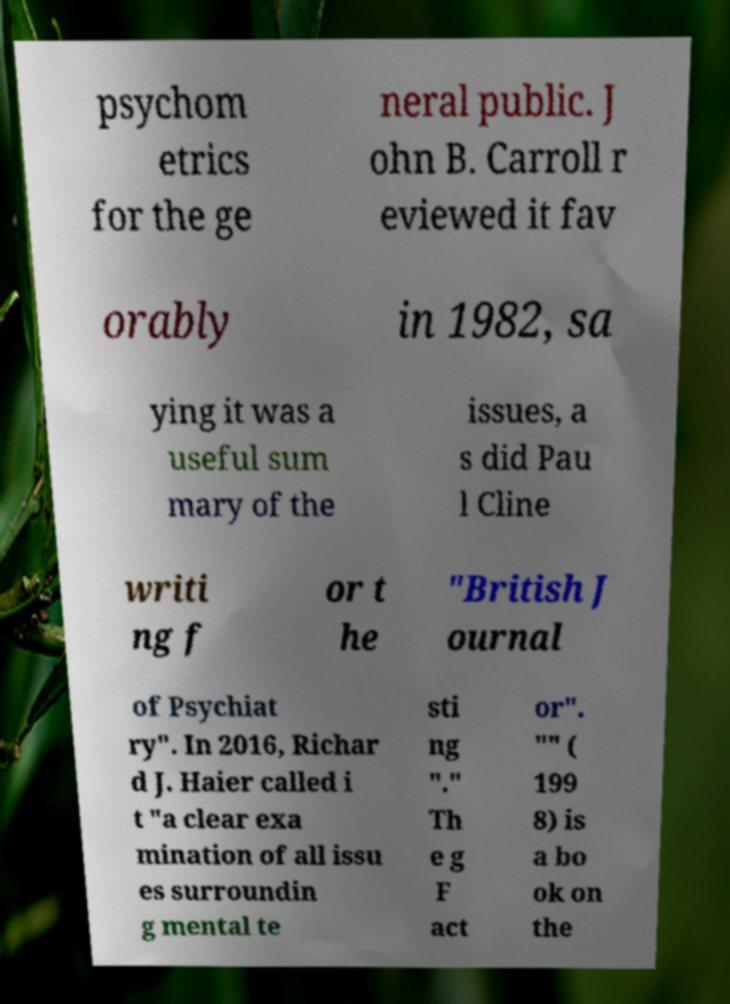What messages or text are displayed in this image? I need them in a readable, typed format. psychom etrics for the ge neral public. J ohn B. Carroll r eviewed it fav orably in 1982, sa ying it was a useful sum mary of the issues, a s did Pau l Cline writi ng f or t he "British J ournal of Psychiat ry". In 2016, Richar d J. Haier called i t "a clear exa mination of all issu es surroundin g mental te sti ng "." Th e g F act or". "" ( 199 8) is a bo ok on the 